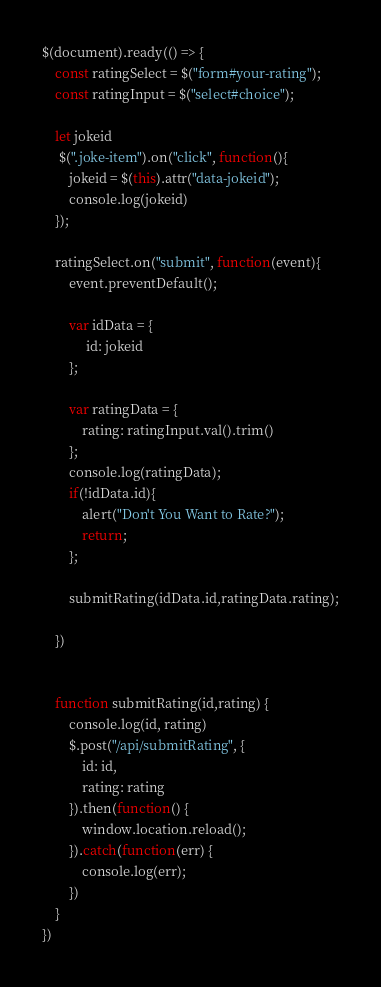<code> <loc_0><loc_0><loc_500><loc_500><_JavaScript_>$(document).ready(() => {
    const ratingSelect = $("form#your-rating");
    const ratingInput = $("select#choice");
    
    let jokeid
     $(".joke-item").on("click", function(){
        jokeid = $(this).attr("data-jokeid");
        console.log(jokeid)
    });
    
    ratingSelect.on("submit", function(event){
        event.preventDefault();
        
        var idData = {
             id: jokeid
        };
        
        var ratingData = {
            rating: ratingInput.val().trim()
        };
        console.log(ratingData);
        if(!idData.id){
            alert("Don't You Want to Rate?");
            return;
        };

        submitRating(idData.id,ratingData.rating);
        
    })

   
    function submitRating(id,rating) {
        console.log(id, rating)
        $.post("/api/submitRating", {
            id: id,
            rating: rating
        }).then(function() {
            window.location.reload();
        }).catch(function(err) {
            console.log(err);
        })
    }
})</code> 